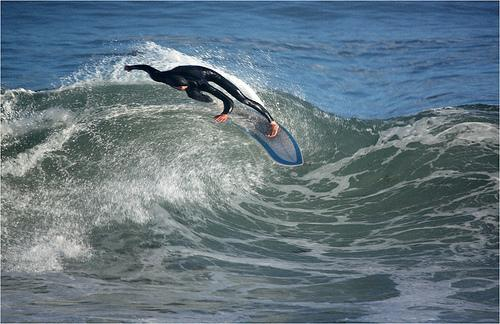What are the colors evident in the surfboard's design? The surfboard has a blue edge and a white main body. What does the surfer seem to be navigating through on his surfboard, as per the image details? The surfer is navigating through a foamy rolling wave in a vast blue ocean. Identify the color and type of clothing worn by the person in the image. The person is wearing a black wetsuit. Explain the main subject's technique to maintain balance while performing the activity. The surfer extends his arm and uses his bare hand and bare foot for balance while riding the wave. In a creative manner, recount the image's main subject's experience. Fearlessly, the surfer conquers the mighty ocean wave, seeking an adrenaline-fueled thrill and a true connection with nature on his vibrant blue and white surfboard. Describe the appearance of the surfboard in the image. The surfboard is white and blue, with a blue edge and white main body. Identify the actions and equipment involved in the main subject's activity. The main subject is surfing a wave on a blue and white surfboard, wearing a black wetsuit, and using his bare hand and bare foot for balance. Name three features mentioned in the captions that describe aspects of the water or wave. White spray from the wave, rough blue water, and foamy rolling wave. In one sentence, describe the overall scene depicted in the image. A surfer in a black wetsuit riding a foamy wave on a blue and white surfboard in a large, blue ocean. Using the given image details, describe the state of the ocean. Large, vast blue ocean with rough water and small, foamy waves Recognize the main activity happening in the image. Surfing What is the color of the surfboard seen in the image? Blue and white Provide an informal description of the image. There's this dude surfing on a foamy wave with a cool blue and white board, and he's wearing a black wetsuit. Describe the scene shown in the image. A person wearing a black wetsuit is surfing a wave with a blue and white surfboard in a large body of blue water. Can you recognize any emotions or expressions from the image information provided? No, the image information does not give enough detail for recognizing emotions or expressions. Determine the objects involved in the observed activity in the image. Individual wearing a wetsuit, surfboard, waves, and ocean Can you point out the seagull flying above the surfer in the picture? There is a seagull perched on the surfboard hissing at the person riding the wave. Identify the key components of the image related to the event happening. Person wearing a wetsuit, blue and white surfboard, foamy wave, and vast blue ocean Please create a media caption based on the image details. "Thrill-seeker defies the waves: Surfer rides the crest of a foamy wave decked in a black wetsuit on a white and blue surfboard." Select the correct description of the picture from the following options: 1. A person surfing on calm water, 2. A person riding a bicycle, 3. A person surfing a wave wearing a wetsuit. 3. A person surfing a wave wearing a wetsuit Examine the picture and describe the condition of the water. The water is rough and has high waves with foam and spray. Create a catchy headline for the given image data. "Catching the Waves: A Daring Surfer Rides the Ocean in Style!" Can you locate the surfer's pet dog swimming towards him? Capture the adorable dog's wagging tail splashing water onto its owner. Where is the shark fin peeping out of the water near the surfer? Make sure to circle the shadow of a lurking shark in the deep blue ocean. Find the lighthouse in the distance at the horizon. Is there a boat passing by the lighthouse, leaving a trail of white foam in the water? Write a brief, formal description of the image.  The image portrays an individual in a black wetsuit who is riding the crest of a wave atop a blue and white surfboard. Where is the little boy on the beach building a sandcastle to the right of the surfer? Make sure to notice the colorful beach towel and sunglasses next to the boy. Can you see the woman holding a beach ball in the sand at the edge of the image? Look for a beach umbrella and a group of people playing volleyball nearby. Describe the surfer's outfit in the image. The surfer is wearing a full black wetsuit. None of the captions refer to a lighthouse, boat, or any distant objects on the horizon in the image. Presenting the lighthouse and the boat would distract the viewer from the actual elements and lead them to find non-existing items in the image. No, it's not mentioned in the image. Provide a description of the surfboard seen in the picture. The surfboard is white with a blue edge. Detect the primary event occurring in the picture. A person surfing a wave 